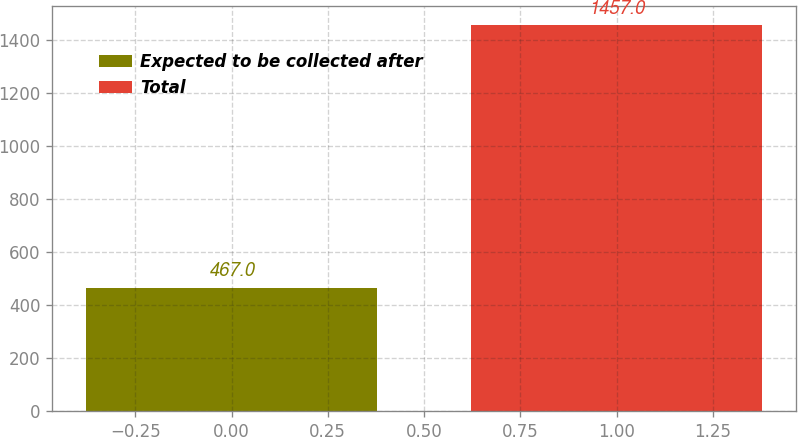Convert chart. <chart><loc_0><loc_0><loc_500><loc_500><bar_chart><fcel>Expected to be collected after<fcel>Total<nl><fcel>467<fcel>1457<nl></chart> 